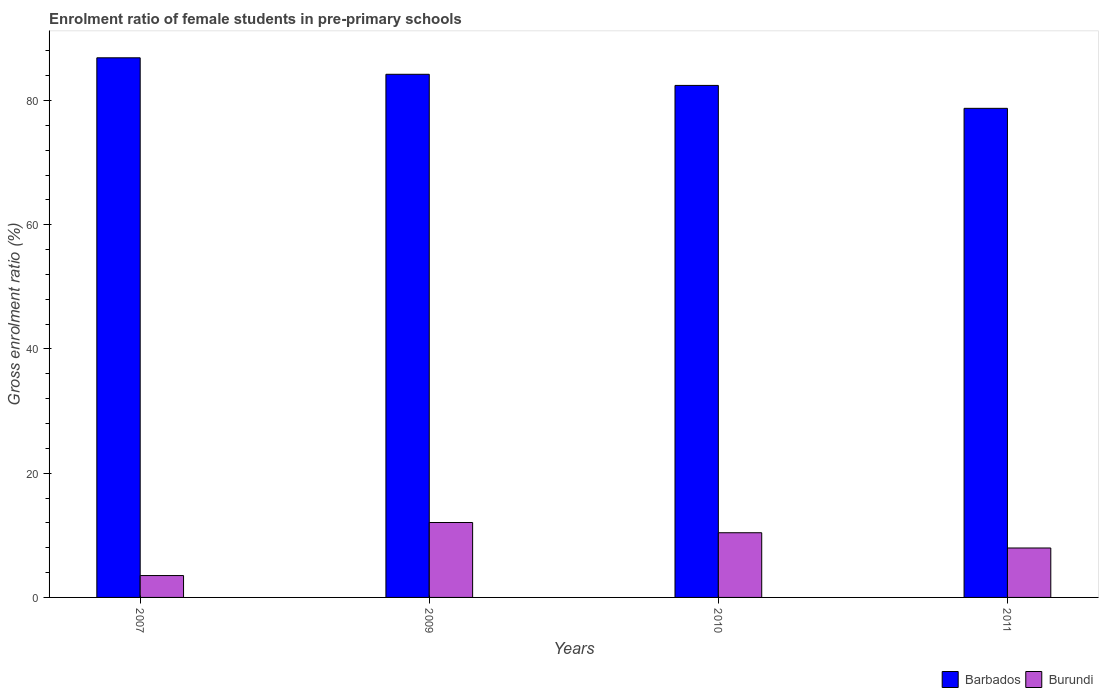How many different coloured bars are there?
Offer a terse response. 2. How many groups of bars are there?
Offer a very short reply. 4. Are the number of bars per tick equal to the number of legend labels?
Your response must be concise. Yes. Are the number of bars on each tick of the X-axis equal?
Your answer should be very brief. Yes. How many bars are there on the 1st tick from the right?
Offer a terse response. 2. What is the label of the 2nd group of bars from the left?
Keep it short and to the point. 2009. In how many cases, is the number of bars for a given year not equal to the number of legend labels?
Offer a terse response. 0. What is the enrolment ratio of female students in pre-primary schools in Barbados in 2007?
Your answer should be compact. 86.87. Across all years, what is the maximum enrolment ratio of female students in pre-primary schools in Burundi?
Provide a succinct answer. 12.06. Across all years, what is the minimum enrolment ratio of female students in pre-primary schools in Burundi?
Offer a very short reply. 3.52. In which year was the enrolment ratio of female students in pre-primary schools in Burundi minimum?
Make the answer very short. 2007. What is the total enrolment ratio of female students in pre-primary schools in Burundi in the graph?
Your answer should be very brief. 33.95. What is the difference between the enrolment ratio of female students in pre-primary schools in Barbados in 2009 and that in 2011?
Your response must be concise. 5.48. What is the difference between the enrolment ratio of female students in pre-primary schools in Barbados in 2010 and the enrolment ratio of female students in pre-primary schools in Burundi in 2009?
Your answer should be very brief. 70.36. What is the average enrolment ratio of female students in pre-primary schools in Barbados per year?
Ensure brevity in your answer.  83.06. In the year 2007, what is the difference between the enrolment ratio of female students in pre-primary schools in Burundi and enrolment ratio of female students in pre-primary schools in Barbados?
Your answer should be very brief. -83.35. In how many years, is the enrolment ratio of female students in pre-primary schools in Barbados greater than 52 %?
Offer a very short reply. 4. What is the ratio of the enrolment ratio of female students in pre-primary schools in Barbados in 2009 to that in 2011?
Give a very brief answer. 1.07. What is the difference between the highest and the second highest enrolment ratio of female students in pre-primary schools in Burundi?
Make the answer very short. 1.65. What is the difference between the highest and the lowest enrolment ratio of female students in pre-primary schools in Burundi?
Your answer should be very brief. 8.54. What does the 2nd bar from the left in 2009 represents?
Provide a succinct answer. Burundi. What does the 1st bar from the right in 2011 represents?
Keep it short and to the point. Burundi. How many bars are there?
Your response must be concise. 8. Does the graph contain any zero values?
Give a very brief answer. No. Does the graph contain grids?
Keep it short and to the point. No. Where does the legend appear in the graph?
Keep it short and to the point. Bottom right. How are the legend labels stacked?
Your answer should be compact. Horizontal. What is the title of the graph?
Your response must be concise. Enrolment ratio of female students in pre-primary schools. What is the label or title of the X-axis?
Keep it short and to the point. Years. What is the Gross enrolment ratio (%) in Barbados in 2007?
Offer a very short reply. 86.87. What is the Gross enrolment ratio (%) of Burundi in 2007?
Make the answer very short. 3.52. What is the Gross enrolment ratio (%) of Barbados in 2009?
Offer a terse response. 84.21. What is the Gross enrolment ratio (%) in Burundi in 2009?
Keep it short and to the point. 12.06. What is the Gross enrolment ratio (%) of Barbados in 2010?
Offer a terse response. 82.42. What is the Gross enrolment ratio (%) in Burundi in 2010?
Your response must be concise. 10.41. What is the Gross enrolment ratio (%) in Barbados in 2011?
Your answer should be compact. 78.73. What is the Gross enrolment ratio (%) of Burundi in 2011?
Make the answer very short. 7.96. Across all years, what is the maximum Gross enrolment ratio (%) of Barbados?
Your answer should be compact. 86.87. Across all years, what is the maximum Gross enrolment ratio (%) of Burundi?
Offer a very short reply. 12.06. Across all years, what is the minimum Gross enrolment ratio (%) of Barbados?
Give a very brief answer. 78.73. Across all years, what is the minimum Gross enrolment ratio (%) of Burundi?
Ensure brevity in your answer.  3.52. What is the total Gross enrolment ratio (%) of Barbados in the graph?
Provide a short and direct response. 332.24. What is the total Gross enrolment ratio (%) in Burundi in the graph?
Your response must be concise. 33.95. What is the difference between the Gross enrolment ratio (%) in Barbados in 2007 and that in 2009?
Provide a short and direct response. 2.65. What is the difference between the Gross enrolment ratio (%) in Burundi in 2007 and that in 2009?
Offer a terse response. -8.54. What is the difference between the Gross enrolment ratio (%) in Barbados in 2007 and that in 2010?
Make the answer very short. 4.45. What is the difference between the Gross enrolment ratio (%) of Burundi in 2007 and that in 2010?
Provide a short and direct response. -6.89. What is the difference between the Gross enrolment ratio (%) of Barbados in 2007 and that in 2011?
Give a very brief answer. 8.14. What is the difference between the Gross enrolment ratio (%) of Burundi in 2007 and that in 2011?
Your response must be concise. -4.44. What is the difference between the Gross enrolment ratio (%) of Barbados in 2009 and that in 2010?
Your answer should be very brief. 1.79. What is the difference between the Gross enrolment ratio (%) of Burundi in 2009 and that in 2010?
Offer a terse response. 1.65. What is the difference between the Gross enrolment ratio (%) in Barbados in 2009 and that in 2011?
Provide a succinct answer. 5.48. What is the difference between the Gross enrolment ratio (%) in Burundi in 2009 and that in 2011?
Offer a very short reply. 4.1. What is the difference between the Gross enrolment ratio (%) of Barbados in 2010 and that in 2011?
Offer a terse response. 3.69. What is the difference between the Gross enrolment ratio (%) in Burundi in 2010 and that in 2011?
Your answer should be very brief. 2.46. What is the difference between the Gross enrolment ratio (%) of Barbados in 2007 and the Gross enrolment ratio (%) of Burundi in 2009?
Give a very brief answer. 74.81. What is the difference between the Gross enrolment ratio (%) in Barbados in 2007 and the Gross enrolment ratio (%) in Burundi in 2010?
Provide a short and direct response. 76.45. What is the difference between the Gross enrolment ratio (%) in Barbados in 2007 and the Gross enrolment ratio (%) in Burundi in 2011?
Ensure brevity in your answer.  78.91. What is the difference between the Gross enrolment ratio (%) in Barbados in 2009 and the Gross enrolment ratio (%) in Burundi in 2010?
Offer a terse response. 73.8. What is the difference between the Gross enrolment ratio (%) in Barbados in 2009 and the Gross enrolment ratio (%) in Burundi in 2011?
Give a very brief answer. 76.26. What is the difference between the Gross enrolment ratio (%) of Barbados in 2010 and the Gross enrolment ratio (%) of Burundi in 2011?
Keep it short and to the point. 74.47. What is the average Gross enrolment ratio (%) in Barbados per year?
Provide a succinct answer. 83.06. What is the average Gross enrolment ratio (%) in Burundi per year?
Provide a short and direct response. 8.49. In the year 2007, what is the difference between the Gross enrolment ratio (%) in Barbados and Gross enrolment ratio (%) in Burundi?
Your answer should be very brief. 83.35. In the year 2009, what is the difference between the Gross enrolment ratio (%) in Barbados and Gross enrolment ratio (%) in Burundi?
Your answer should be very brief. 72.16. In the year 2010, what is the difference between the Gross enrolment ratio (%) in Barbados and Gross enrolment ratio (%) in Burundi?
Give a very brief answer. 72.01. In the year 2011, what is the difference between the Gross enrolment ratio (%) of Barbados and Gross enrolment ratio (%) of Burundi?
Your answer should be compact. 70.78. What is the ratio of the Gross enrolment ratio (%) of Barbados in 2007 to that in 2009?
Offer a very short reply. 1.03. What is the ratio of the Gross enrolment ratio (%) in Burundi in 2007 to that in 2009?
Your response must be concise. 0.29. What is the ratio of the Gross enrolment ratio (%) in Barbados in 2007 to that in 2010?
Provide a short and direct response. 1.05. What is the ratio of the Gross enrolment ratio (%) in Burundi in 2007 to that in 2010?
Make the answer very short. 0.34. What is the ratio of the Gross enrolment ratio (%) of Barbados in 2007 to that in 2011?
Offer a very short reply. 1.1. What is the ratio of the Gross enrolment ratio (%) in Burundi in 2007 to that in 2011?
Provide a succinct answer. 0.44. What is the ratio of the Gross enrolment ratio (%) of Barbados in 2009 to that in 2010?
Offer a very short reply. 1.02. What is the ratio of the Gross enrolment ratio (%) of Burundi in 2009 to that in 2010?
Give a very brief answer. 1.16. What is the ratio of the Gross enrolment ratio (%) in Barbados in 2009 to that in 2011?
Ensure brevity in your answer.  1.07. What is the ratio of the Gross enrolment ratio (%) of Burundi in 2009 to that in 2011?
Provide a short and direct response. 1.52. What is the ratio of the Gross enrolment ratio (%) of Barbados in 2010 to that in 2011?
Provide a succinct answer. 1.05. What is the ratio of the Gross enrolment ratio (%) in Burundi in 2010 to that in 2011?
Provide a short and direct response. 1.31. What is the difference between the highest and the second highest Gross enrolment ratio (%) in Barbados?
Make the answer very short. 2.65. What is the difference between the highest and the second highest Gross enrolment ratio (%) of Burundi?
Ensure brevity in your answer.  1.65. What is the difference between the highest and the lowest Gross enrolment ratio (%) of Barbados?
Provide a succinct answer. 8.14. What is the difference between the highest and the lowest Gross enrolment ratio (%) in Burundi?
Keep it short and to the point. 8.54. 